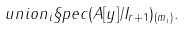<formula> <loc_0><loc_0><loc_500><loc_500>\ u n i o n _ { i } \S p e c ( A [ y ] / I _ { r + 1 } ) _ { ( m _ { i } ) } .</formula> 